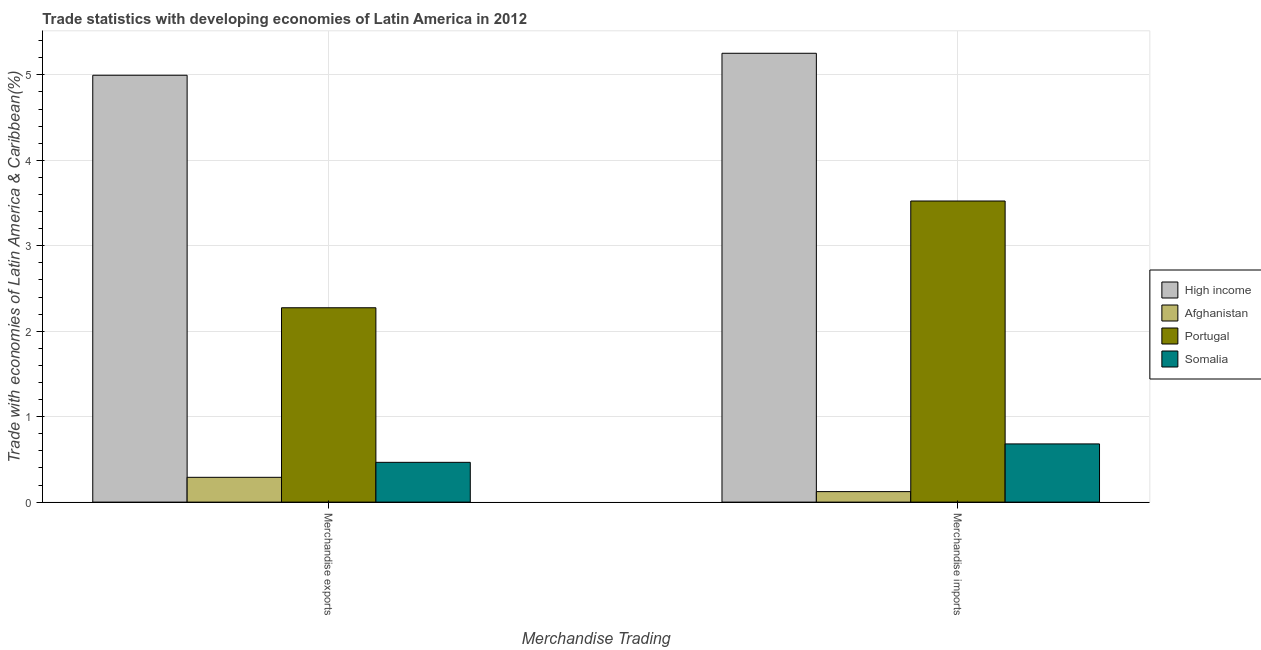How many different coloured bars are there?
Ensure brevity in your answer.  4. Are the number of bars per tick equal to the number of legend labels?
Provide a succinct answer. Yes. Are the number of bars on each tick of the X-axis equal?
Provide a short and direct response. Yes. How many bars are there on the 2nd tick from the left?
Your answer should be compact. 4. What is the merchandise imports in Somalia?
Your answer should be very brief. 0.68. Across all countries, what is the maximum merchandise imports?
Your answer should be compact. 5.25. Across all countries, what is the minimum merchandise exports?
Give a very brief answer. 0.29. In which country was the merchandise imports minimum?
Provide a succinct answer. Afghanistan. What is the total merchandise imports in the graph?
Your answer should be compact. 9.58. What is the difference between the merchandise imports in Somalia and that in High income?
Provide a short and direct response. -4.57. What is the difference between the merchandise exports in Afghanistan and the merchandise imports in Portugal?
Your answer should be compact. -3.23. What is the average merchandise imports per country?
Offer a terse response. 2.39. What is the difference between the merchandise imports and merchandise exports in High income?
Give a very brief answer. 0.26. In how many countries, is the merchandise exports greater than 1 %?
Provide a short and direct response. 2. What is the ratio of the merchandise exports in High income to that in Afghanistan?
Offer a very short reply. 17.21. In how many countries, is the merchandise exports greater than the average merchandise exports taken over all countries?
Your answer should be compact. 2. What does the 2nd bar from the left in Merchandise imports represents?
Offer a terse response. Afghanistan. How many countries are there in the graph?
Your answer should be very brief. 4. What is the difference between two consecutive major ticks on the Y-axis?
Your response must be concise. 1. Does the graph contain grids?
Offer a terse response. Yes. Where does the legend appear in the graph?
Offer a very short reply. Center right. How many legend labels are there?
Offer a terse response. 4. How are the legend labels stacked?
Provide a short and direct response. Vertical. What is the title of the graph?
Your answer should be compact. Trade statistics with developing economies of Latin America in 2012. What is the label or title of the X-axis?
Give a very brief answer. Merchandise Trading. What is the label or title of the Y-axis?
Offer a terse response. Trade with economies of Latin America & Caribbean(%). What is the Trade with economies of Latin America & Caribbean(%) of High income in Merchandise exports?
Your response must be concise. 5. What is the Trade with economies of Latin America & Caribbean(%) of Afghanistan in Merchandise exports?
Your answer should be very brief. 0.29. What is the Trade with economies of Latin America & Caribbean(%) in Portugal in Merchandise exports?
Provide a short and direct response. 2.27. What is the Trade with economies of Latin America & Caribbean(%) in Somalia in Merchandise exports?
Your response must be concise. 0.47. What is the Trade with economies of Latin America & Caribbean(%) of High income in Merchandise imports?
Make the answer very short. 5.25. What is the Trade with economies of Latin America & Caribbean(%) in Afghanistan in Merchandise imports?
Your answer should be very brief. 0.12. What is the Trade with economies of Latin America & Caribbean(%) of Portugal in Merchandise imports?
Provide a short and direct response. 3.52. What is the Trade with economies of Latin America & Caribbean(%) in Somalia in Merchandise imports?
Provide a short and direct response. 0.68. Across all Merchandise Trading, what is the maximum Trade with economies of Latin America & Caribbean(%) in High income?
Offer a terse response. 5.25. Across all Merchandise Trading, what is the maximum Trade with economies of Latin America & Caribbean(%) in Afghanistan?
Make the answer very short. 0.29. Across all Merchandise Trading, what is the maximum Trade with economies of Latin America & Caribbean(%) of Portugal?
Keep it short and to the point. 3.52. Across all Merchandise Trading, what is the maximum Trade with economies of Latin America & Caribbean(%) in Somalia?
Offer a terse response. 0.68. Across all Merchandise Trading, what is the minimum Trade with economies of Latin America & Caribbean(%) of High income?
Offer a terse response. 5. Across all Merchandise Trading, what is the minimum Trade with economies of Latin America & Caribbean(%) of Afghanistan?
Your answer should be very brief. 0.12. Across all Merchandise Trading, what is the minimum Trade with economies of Latin America & Caribbean(%) of Portugal?
Give a very brief answer. 2.27. Across all Merchandise Trading, what is the minimum Trade with economies of Latin America & Caribbean(%) of Somalia?
Your response must be concise. 0.47. What is the total Trade with economies of Latin America & Caribbean(%) in High income in the graph?
Offer a very short reply. 10.25. What is the total Trade with economies of Latin America & Caribbean(%) of Afghanistan in the graph?
Offer a terse response. 0.41. What is the total Trade with economies of Latin America & Caribbean(%) of Portugal in the graph?
Keep it short and to the point. 5.8. What is the total Trade with economies of Latin America & Caribbean(%) in Somalia in the graph?
Your answer should be very brief. 1.15. What is the difference between the Trade with economies of Latin America & Caribbean(%) in High income in Merchandise exports and that in Merchandise imports?
Give a very brief answer. -0.26. What is the difference between the Trade with economies of Latin America & Caribbean(%) in Afghanistan in Merchandise exports and that in Merchandise imports?
Your response must be concise. 0.17. What is the difference between the Trade with economies of Latin America & Caribbean(%) of Portugal in Merchandise exports and that in Merchandise imports?
Your answer should be very brief. -1.25. What is the difference between the Trade with economies of Latin America & Caribbean(%) in Somalia in Merchandise exports and that in Merchandise imports?
Your response must be concise. -0.22. What is the difference between the Trade with economies of Latin America & Caribbean(%) of High income in Merchandise exports and the Trade with economies of Latin America & Caribbean(%) of Afghanistan in Merchandise imports?
Make the answer very short. 4.87. What is the difference between the Trade with economies of Latin America & Caribbean(%) of High income in Merchandise exports and the Trade with economies of Latin America & Caribbean(%) of Portugal in Merchandise imports?
Provide a short and direct response. 1.47. What is the difference between the Trade with economies of Latin America & Caribbean(%) in High income in Merchandise exports and the Trade with economies of Latin America & Caribbean(%) in Somalia in Merchandise imports?
Give a very brief answer. 4.31. What is the difference between the Trade with economies of Latin America & Caribbean(%) in Afghanistan in Merchandise exports and the Trade with economies of Latin America & Caribbean(%) in Portugal in Merchandise imports?
Offer a very short reply. -3.23. What is the difference between the Trade with economies of Latin America & Caribbean(%) of Afghanistan in Merchandise exports and the Trade with economies of Latin America & Caribbean(%) of Somalia in Merchandise imports?
Your answer should be very brief. -0.39. What is the difference between the Trade with economies of Latin America & Caribbean(%) in Portugal in Merchandise exports and the Trade with economies of Latin America & Caribbean(%) in Somalia in Merchandise imports?
Make the answer very short. 1.59. What is the average Trade with economies of Latin America & Caribbean(%) in High income per Merchandise Trading?
Make the answer very short. 5.12. What is the average Trade with economies of Latin America & Caribbean(%) in Afghanistan per Merchandise Trading?
Provide a short and direct response. 0.21. What is the average Trade with economies of Latin America & Caribbean(%) in Portugal per Merchandise Trading?
Offer a very short reply. 2.9. What is the average Trade with economies of Latin America & Caribbean(%) of Somalia per Merchandise Trading?
Offer a very short reply. 0.57. What is the difference between the Trade with economies of Latin America & Caribbean(%) in High income and Trade with economies of Latin America & Caribbean(%) in Afghanistan in Merchandise exports?
Provide a short and direct response. 4.7. What is the difference between the Trade with economies of Latin America & Caribbean(%) of High income and Trade with economies of Latin America & Caribbean(%) of Portugal in Merchandise exports?
Keep it short and to the point. 2.72. What is the difference between the Trade with economies of Latin America & Caribbean(%) in High income and Trade with economies of Latin America & Caribbean(%) in Somalia in Merchandise exports?
Your response must be concise. 4.53. What is the difference between the Trade with economies of Latin America & Caribbean(%) in Afghanistan and Trade with economies of Latin America & Caribbean(%) in Portugal in Merchandise exports?
Your response must be concise. -1.98. What is the difference between the Trade with economies of Latin America & Caribbean(%) in Afghanistan and Trade with economies of Latin America & Caribbean(%) in Somalia in Merchandise exports?
Your answer should be very brief. -0.18. What is the difference between the Trade with economies of Latin America & Caribbean(%) of Portugal and Trade with economies of Latin America & Caribbean(%) of Somalia in Merchandise exports?
Offer a terse response. 1.81. What is the difference between the Trade with economies of Latin America & Caribbean(%) of High income and Trade with economies of Latin America & Caribbean(%) of Afghanistan in Merchandise imports?
Offer a very short reply. 5.13. What is the difference between the Trade with economies of Latin America & Caribbean(%) in High income and Trade with economies of Latin America & Caribbean(%) in Portugal in Merchandise imports?
Give a very brief answer. 1.73. What is the difference between the Trade with economies of Latin America & Caribbean(%) in High income and Trade with economies of Latin America & Caribbean(%) in Somalia in Merchandise imports?
Your answer should be very brief. 4.57. What is the difference between the Trade with economies of Latin America & Caribbean(%) of Afghanistan and Trade with economies of Latin America & Caribbean(%) of Portugal in Merchandise imports?
Keep it short and to the point. -3.4. What is the difference between the Trade with economies of Latin America & Caribbean(%) of Afghanistan and Trade with economies of Latin America & Caribbean(%) of Somalia in Merchandise imports?
Make the answer very short. -0.56. What is the difference between the Trade with economies of Latin America & Caribbean(%) of Portugal and Trade with economies of Latin America & Caribbean(%) of Somalia in Merchandise imports?
Make the answer very short. 2.84. What is the ratio of the Trade with economies of Latin America & Caribbean(%) in High income in Merchandise exports to that in Merchandise imports?
Offer a terse response. 0.95. What is the ratio of the Trade with economies of Latin America & Caribbean(%) in Afghanistan in Merchandise exports to that in Merchandise imports?
Make the answer very short. 2.36. What is the ratio of the Trade with economies of Latin America & Caribbean(%) in Portugal in Merchandise exports to that in Merchandise imports?
Ensure brevity in your answer.  0.65. What is the ratio of the Trade with economies of Latin America & Caribbean(%) of Somalia in Merchandise exports to that in Merchandise imports?
Offer a very short reply. 0.68. What is the difference between the highest and the second highest Trade with economies of Latin America & Caribbean(%) of High income?
Provide a succinct answer. 0.26. What is the difference between the highest and the second highest Trade with economies of Latin America & Caribbean(%) of Afghanistan?
Keep it short and to the point. 0.17. What is the difference between the highest and the second highest Trade with economies of Latin America & Caribbean(%) of Portugal?
Provide a succinct answer. 1.25. What is the difference between the highest and the second highest Trade with economies of Latin America & Caribbean(%) of Somalia?
Make the answer very short. 0.22. What is the difference between the highest and the lowest Trade with economies of Latin America & Caribbean(%) in High income?
Make the answer very short. 0.26. What is the difference between the highest and the lowest Trade with economies of Latin America & Caribbean(%) of Afghanistan?
Give a very brief answer. 0.17. What is the difference between the highest and the lowest Trade with economies of Latin America & Caribbean(%) of Portugal?
Your response must be concise. 1.25. What is the difference between the highest and the lowest Trade with economies of Latin America & Caribbean(%) of Somalia?
Your response must be concise. 0.22. 